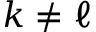Convert formula to latex. <formula><loc_0><loc_0><loc_500><loc_500>k \neq \ell</formula> 